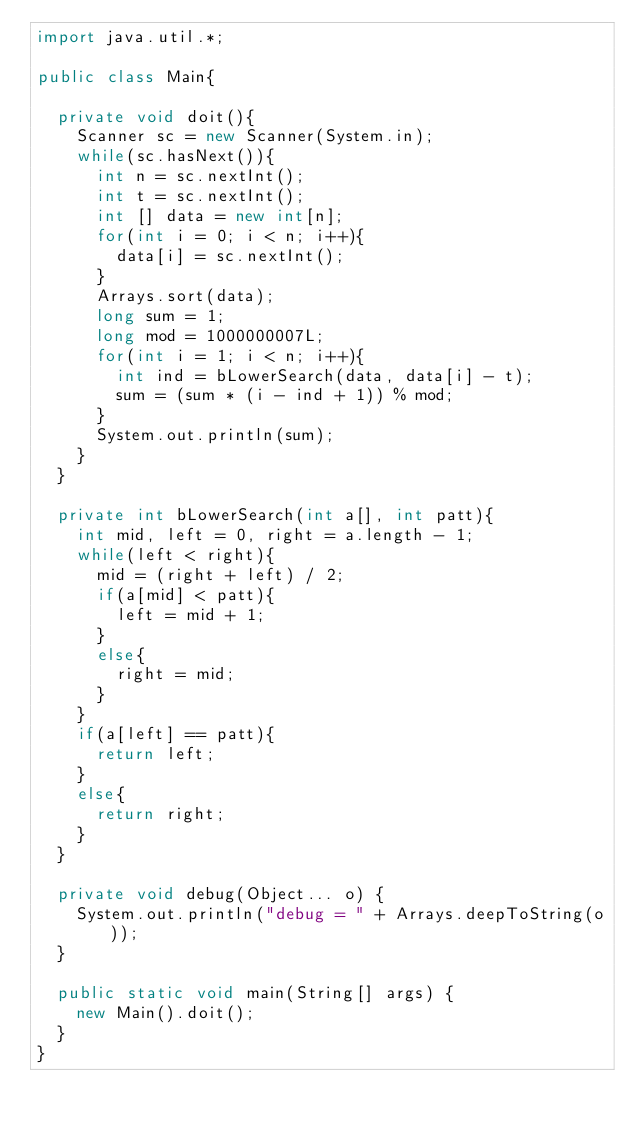<code> <loc_0><loc_0><loc_500><loc_500><_Java_>import java.util.*;

public class Main{
	
	private void doit(){
		Scanner sc = new Scanner(System.in);
		while(sc.hasNext()){
			int n = sc.nextInt();
			int t = sc.nextInt();
			int [] data = new int[n];
			for(int i = 0; i < n; i++){
				data[i] = sc.nextInt();
			}
			Arrays.sort(data);
			long sum = 1;
			long mod = 1000000007L;
			for(int i = 1; i < n; i++){
				int ind = bLowerSearch(data, data[i] - t);
				sum = (sum * (i - ind + 1)) % mod;
			}
			System.out.println(sum);
		}
	}
	
	private int bLowerSearch(int a[], int patt){
		int mid, left = 0, right = a.length - 1;
		while(left < right){
			mid = (right + left) / 2;
			if(a[mid] < patt){
				left = mid + 1;
			}
			else{
				right = mid;
			}
		}
		if(a[left] == patt){
			return left;
		}
		else{
			return right;
		}
	}

	private void debug(Object... o) {
		System.out.println("debug = " + Arrays.deepToString(o));
	}

	public static void main(String[] args) {
		new Main().doit();
	}
}</code> 